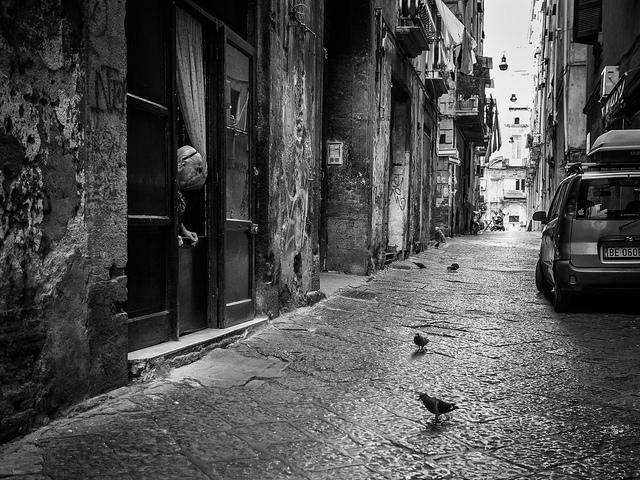How many cars are seen?
Give a very brief answer. 1. 